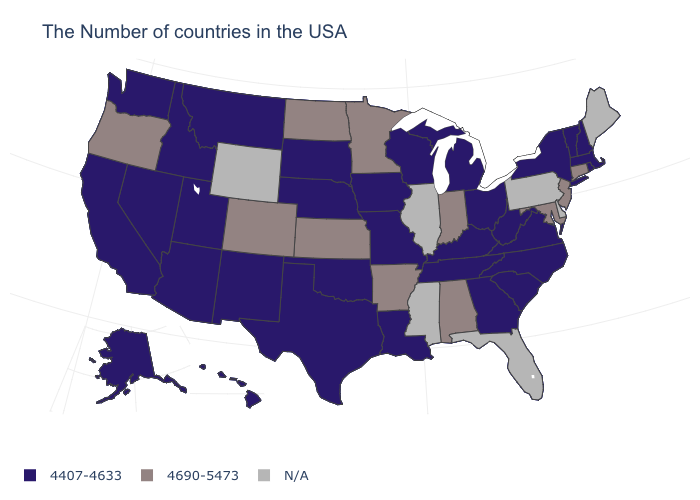Does the first symbol in the legend represent the smallest category?
Keep it brief. Yes. What is the value of Delaware?
Quick response, please. N/A. Does the first symbol in the legend represent the smallest category?
Give a very brief answer. Yes. Name the states that have a value in the range 4407-4633?
Write a very short answer. Massachusetts, Rhode Island, New Hampshire, Vermont, New York, Virginia, North Carolina, South Carolina, West Virginia, Ohio, Georgia, Michigan, Kentucky, Tennessee, Wisconsin, Louisiana, Missouri, Iowa, Nebraska, Oklahoma, Texas, South Dakota, New Mexico, Utah, Montana, Arizona, Idaho, Nevada, California, Washington, Alaska, Hawaii. What is the value of Ohio?
Quick response, please. 4407-4633. Name the states that have a value in the range N/A?
Be succinct. Maine, Delaware, Pennsylvania, Florida, Illinois, Mississippi, Wyoming. Which states have the highest value in the USA?
Answer briefly. Connecticut, New Jersey, Maryland, Indiana, Alabama, Arkansas, Minnesota, Kansas, North Dakota, Colorado, Oregon. Name the states that have a value in the range 4690-5473?
Write a very short answer. Connecticut, New Jersey, Maryland, Indiana, Alabama, Arkansas, Minnesota, Kansas, North Dakota, Colorado, Oregon. Does Minnesota have the highest value in the USA?
Answer briefly. Yes. What is the highest value in the MidWest ?
Concise answer only. 4690-5473. What is the value of Oklahoma?
Give a very brief answer. 4407-4633. Which states hav the highest value in the Northeast?
Give a very brief answer. Connecticut, New Jersey. Which states hav the highest value in the MidWest?
Short answer required. Indiana, Minnesota, Kansas, North Dakota. What is the highest value in the South ?
Give a very brief answer. 4690-5473. Name the states that have a value in the range 4407-4633?
Give a very brief answer. Massachusetts, Rhode Island, New Hampshire, Vermont, New York, Virginia, North Carolina, South Carolina, West Virginia, Ohio, Georgia, Michigan, Kentucky, Tennessee, Wisconsin, Louisiana, Missouri, Iowa, Nebraska, Oklahoma, Texas, South Dakota, New Mexico, Utah, Montana, Arizona, Idaho, Nevada, California, Washington, Alaska, Hawaii. 